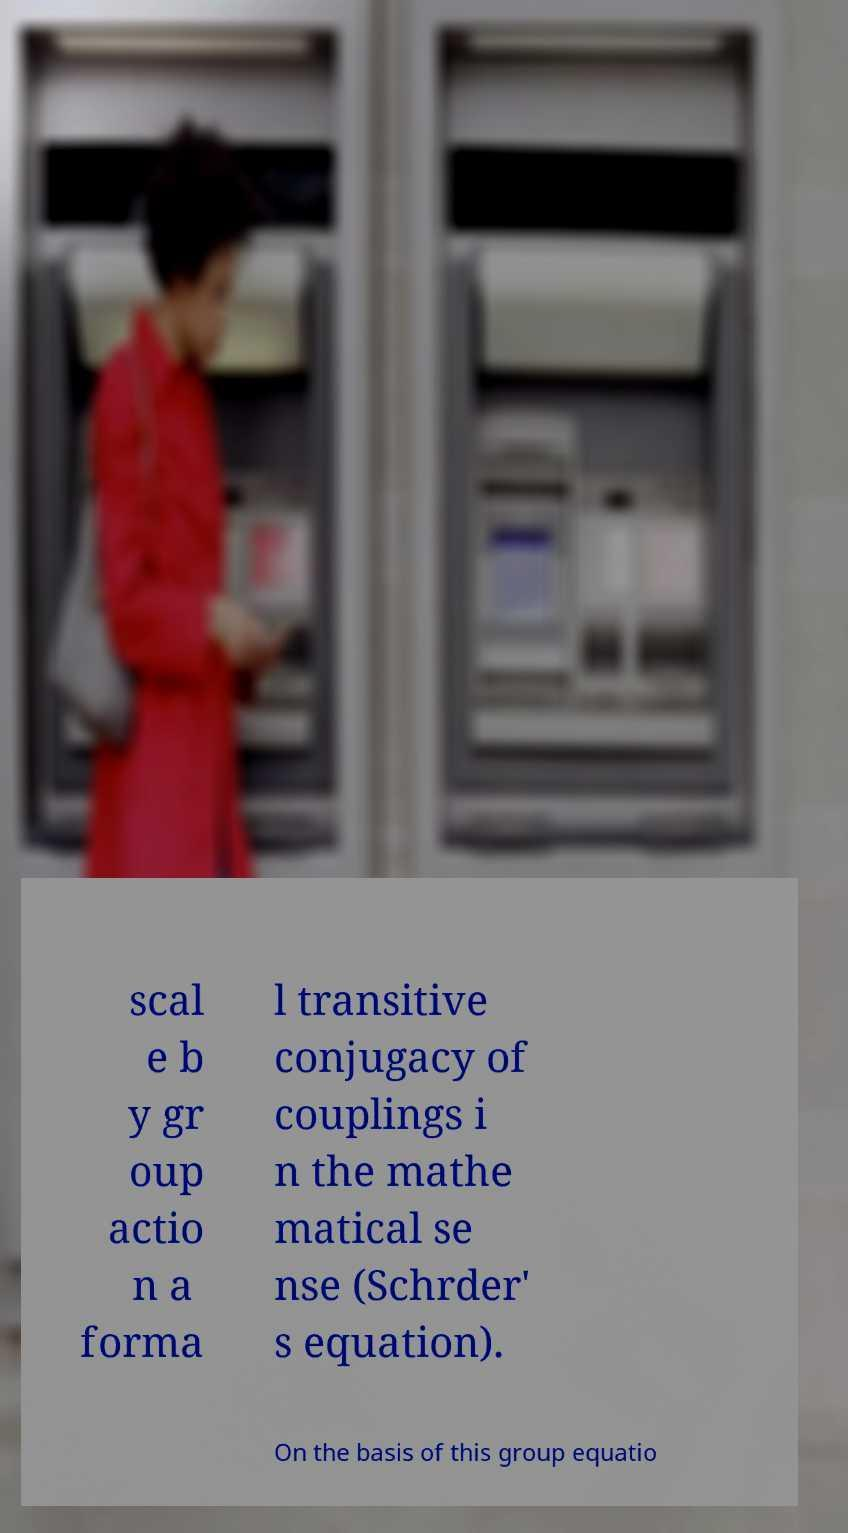Can you read and provide the text displayed in the image?This photo seems to have some interesting text. Can you extract and type it out for me? scal e b y gr oup actio n a forma l transitive conjugacy of couplings i n the mathe matical se nse (Schrder' s equation). On the basis of this group equatio 